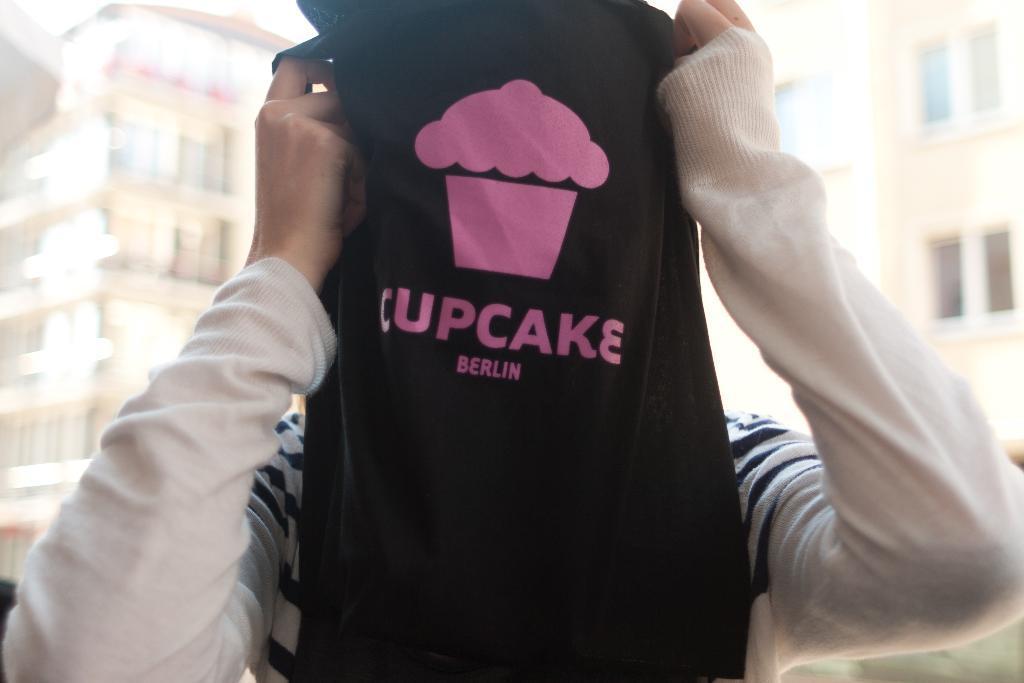Describe this image in one or two sentences. In this image I can see a person wearing white and black colored dress is holding a black colored cloth. In the background I can see few buildings which are cream in color and the sky. 